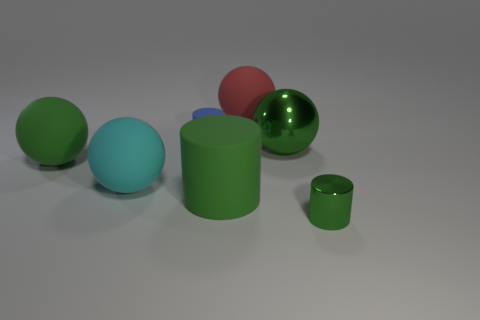There is a large ball that is the same color as the large metal thing; what material is it?
Your response must be concise. Rubber. How many other tiny objects have the same shape as the red object?
Give a very brief answer. 0. There is a tiny cylinder that is on the left side of the tiny green cylinder; is its color the same as the matte sphere that is behind the small matte cylinder?
Give a very brief answer. No. There is a red object that is the same size as the green metallic ball; what is it made of?
Your response must be concise. Rubber. Is there a red matte cylinder of the same size as the metal ball?
Offer a terse response. No. Are there fewer blue objects that are to the right of the small green shiny cylinder than blue matte objects?
Your answer should be very brief. Yes. Are there fewer big red spheres that are behind the tiny green thing than large green matte spheres that are to the right of the small blue thing?
Your answer should be compact. No. What number of spheres are cyan rubber objects or large green things?
Make the answer very short. 3. Do the large object to the left of the large cyan object and the small blue object behind the big cyan ball have the same material?
Your response must be concise. Yes. There is a green shiny object that is the same size as the cyan matte ball; what is its shape?
Offer a terse response. Sphere. 